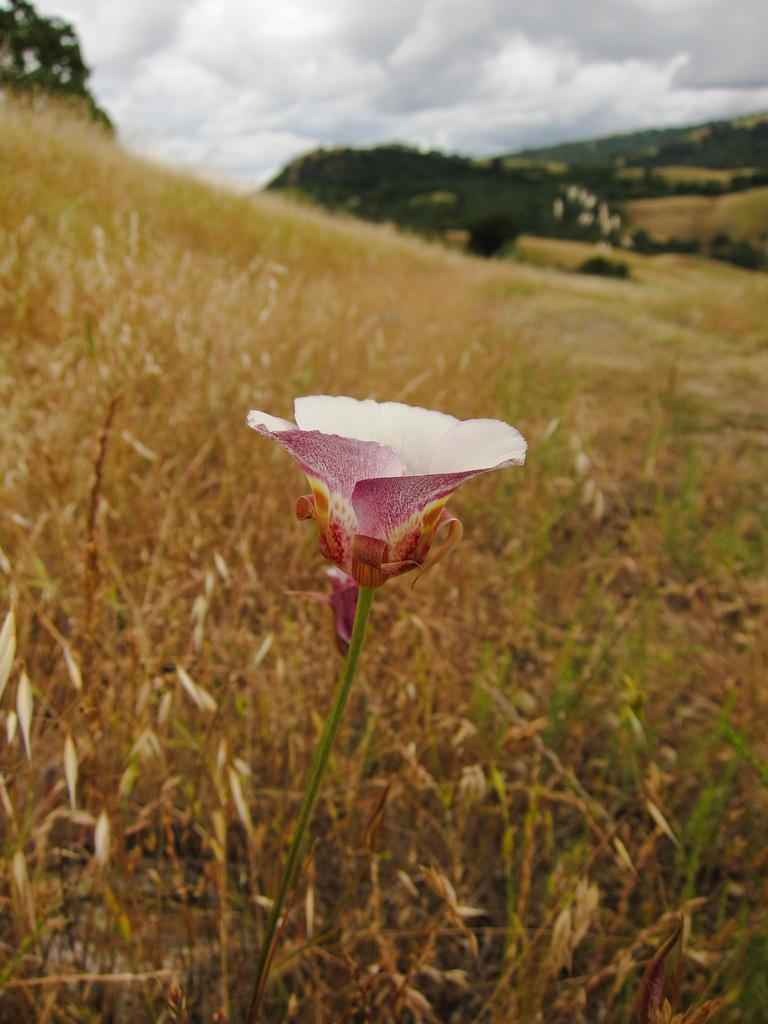What is the main subject of the image? There is a flower in the center of the image. Can you describe the color of the flower? The flower is white and pink in color. What type of vegetation is behind the flower? There is dried grass behind the flower. What can be seen at the top of the image? Trees, hills, and the sky are visible at the top of the image. Is there a home in the image where the flower is being celebrated for its birthday? There is no home or birthday celebration present in the image; it features a flower with dried grass, trees, hills, and the sky in the background. 